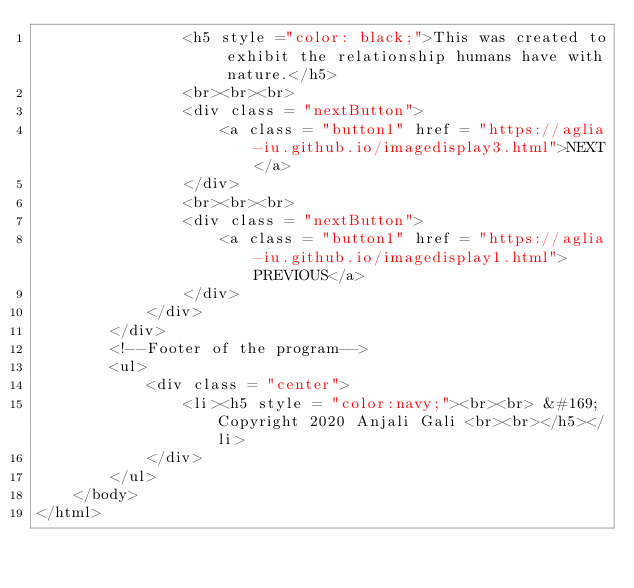Convert code to text. <code><loc_0><loc_0><loc_500><loc_500><_HTML_>                <h5 style ="color: black;">This was created to exhibit the relationship humans have with nature.</h5>
                <br><br><br>
                <div class = "nextButton"> 
                    <a class = "button1" href = "https://aglia-iu.github.io/imagedisplay3.html">NEXT</a>
                </div>
                <br><br><br>
                <div class = "nextButton"> 
                    <a class = "button1" href = "https://aglia-iu.github.io/imagedisplay1.html">PREVIOUS</a>
                </div>
            </div> 
        </div>
        <!--Footer of the program-->
        <ul>
            <div class = "center">
                <li><h5 style = "color:navy;"><br><br> &#169; Copyright 2020 Anjali Gali <br><br></h5></li>
            </div>
        </ul> 
    </body>
</html>
</code> 